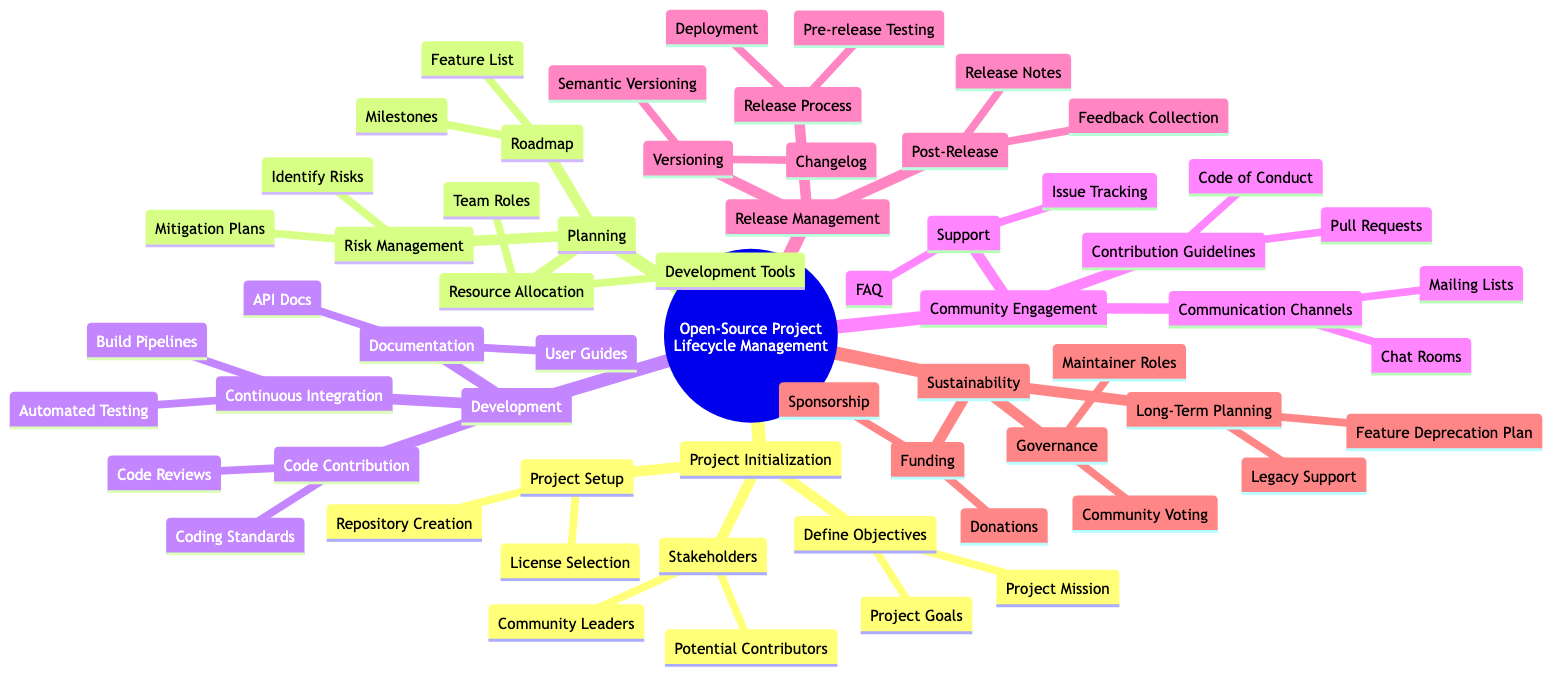What is the first stage of the lifecycle? The first stage represented in the mind map is "Project Initialization." It is clearly delineated and appears as the topmost point leading into the lifecycle management process.
Answer: Project Initialization How many stakeholders are listed in the Project Initialization stage? In the "Project Initialization" section, there are two specific stakeholders mentioned: "Community Leaders" and "Potential Contributors." These are directly linked to the "Stakeholders" node.
Answer: 2 What is one key component of the Development phase under Continuous Integration? "Automated Testing" is a key component mentioned under the "Continuous Integration" section in the "Development" phase, directly listing the practices associated with development processes.
Answer: Automated Testing Which process follows under Post-Release in Release Management? "Feedback Collection" is the next process that introduces the activities following the release of the project, directly related to "Post-Release."
Answer: Feedback Collection What governs the funding aspect of sustainability? "Sponsorship" is listed as one of the elements governing the funding aspect in the "Sustainability" section, indicating a strategy for financial support.
Answer: Sponsorship Why is risk management important in the Planning phase? "Risk Management" is essential because it involves identifying risks and formulating mitigation plans, which are critical for the project's successful planning and execution, showing the interconnectedness with other planning components.
Answer: Identify Risks How many documentation types are mentioned in the Development phase? In the "Development" phase, two types of documentation are mentioned: "API Docs" and "User Guides," providing clarity on what documentation practices are essential.
Answer: 2 Which communication channel is listed in Community Engagement? "Mailing Lists" is one of the communication channels mentioned that facilitate interaction among community members in the "Community Engagement" section.
Answer: Mailing Lists What does the Governance category address in terms of community structure? "Maintainer Roles" is a key address under governance, exploring the responsibilities and organization of ongoing project maintenance in the community structure.
Answer: Maintainer Roles 